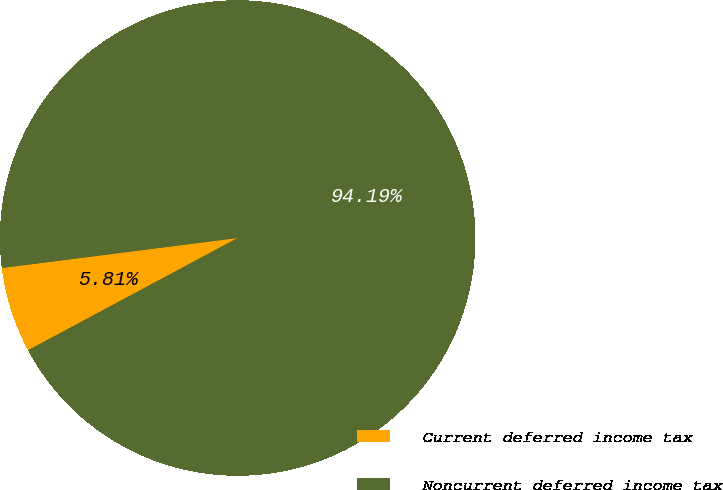Convert chart to OTSL. <chart><loc_0><loc_0><loc_500><loc_500><pie_chart><fcel>Current deferred income tax<fcel>Noncurrent deferred income tax<nl><fcel>5.81%<fcel>94.19%<nl></chart> 